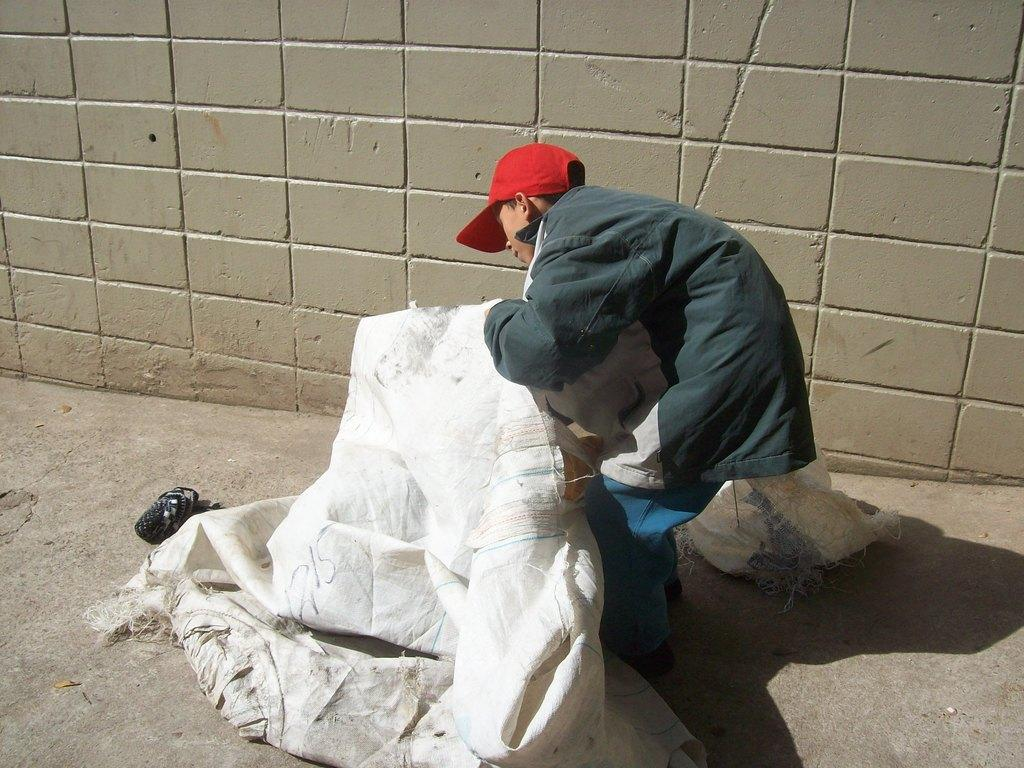Who is present in the image? There is a man in the image. What is the man holding in the image? The man is holding a polypropylene cover. What is the man wearing on his head? The man is wearing a red color cap. Where is the cap positioned in relation to the wall? The cap is visible in front of the wall. What can be seen on the left side of the image? There is an object on the left side of the image. Where is the object located in the image? The object is kept on the floor. What arithmetic problem is the man solving in the image? There is no indication in the image that the man is solving an arithmetic problem. What type of secretary is present in the image? There is no secretary present in the image. 